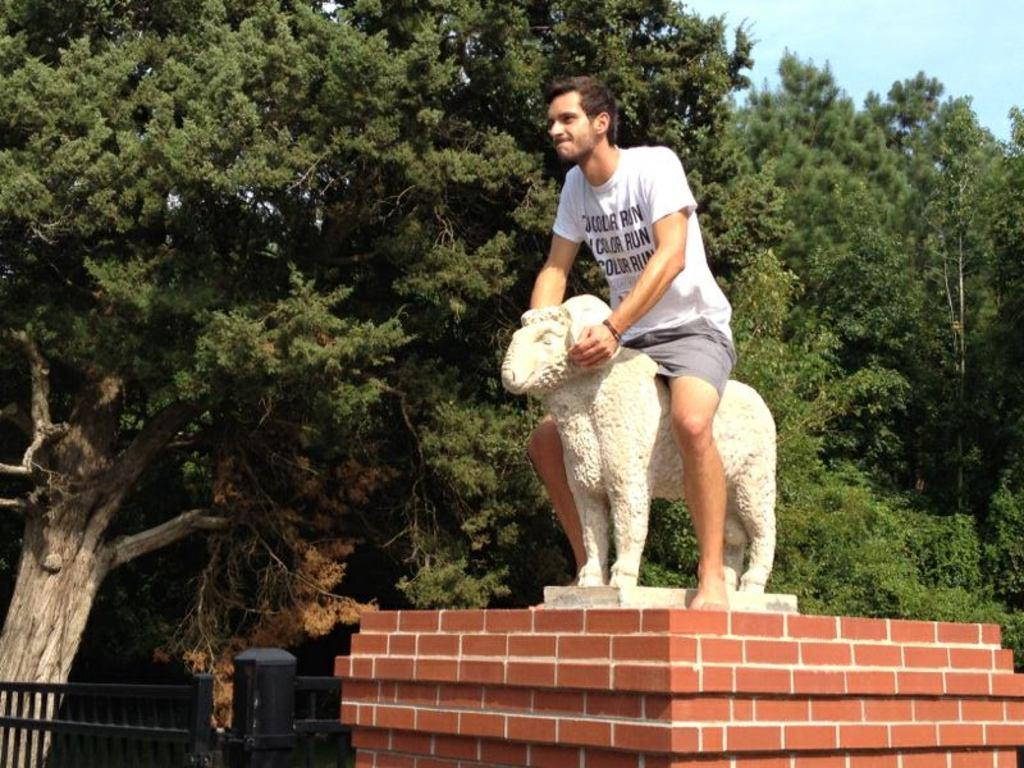What is the main subject of the image? There is a man in the image. What is the man doing in the image? The man is sitting on a statue of a sheep. Can you describe the statue's location? The statue is on a platform. What other elements can be seen in the image? There is a gate and trees in the image, and the sky is visible in the background. What type of twig is the man holding in the image? There is no twig present in the image. Can you see a train passing by in the image? There is no train visible in the image. 